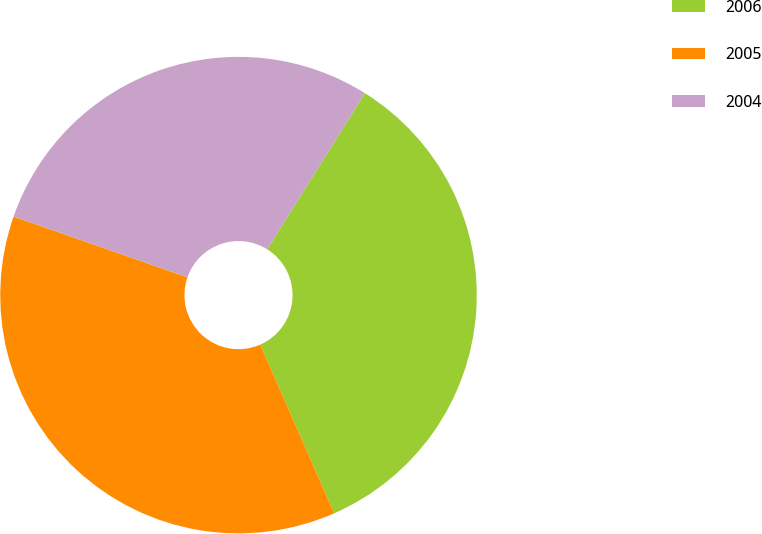<chart> <loc_0><loc_0><loc_500><loc_500><pie_chart><fcel>2006<fcel>2005<fcel>2004<nl><fcel>34.52%<fcel>36.93%<fcel>28.55%<nl></chart> 